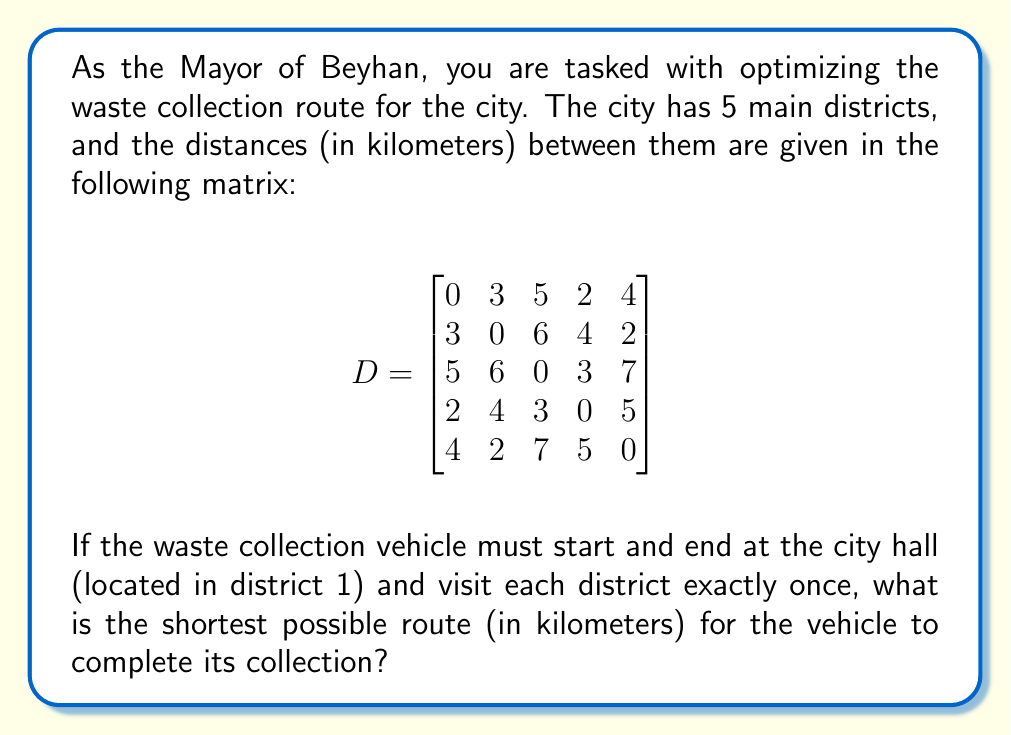Provide a solution to this math problem. To solve this problem, we need to find the shortest Hamiltonian cycle in the given graph, which is known as the Traveling Salesman Problem (TSP). For a small number of districts like this, we can use the brute force method to check all possible routes.

1) First, let's list all possible routes starting and ending at district 1:
   1-2-3-4-5-1
   1-2-3-5-4-1
   1-2-4-3-5-1
   1-2-4-5-3-1
   1-2-5-3-4-1
   1-2-5-4-3-1
   ...and so on (24 routes in total)

2) Now, let's calculate the distance for each route using the given distance matrix. For example, for the route 1-2-3-4-5-1:
   Distance = $D_{12} + D_{23} + D_{34} + D_{45} + D_{51}$
             = 3 + 6 + 3 + 5 + 4 = 21 km

3) We repeat this process for all 24 possible routes and keep track of the shortest one.

4) After checking all routes, we find that the shortest route is 1-4-3-2-5-1 with a total distance of:
   $D_{14} + D_{43} + D_{32} + D_{25} + D_{51}$ = 2 + 3 + 6 + 2 + 4 = 17 km

Therefore, the most efficient route for the waste collection vehicle is to go from district 1 to 4, then to 3, then to 2, then to 5, and finally back to 1, covering a total distance of 17 km.
Answer: The shortest possible route for the waste collection vehicle is 17 km. 